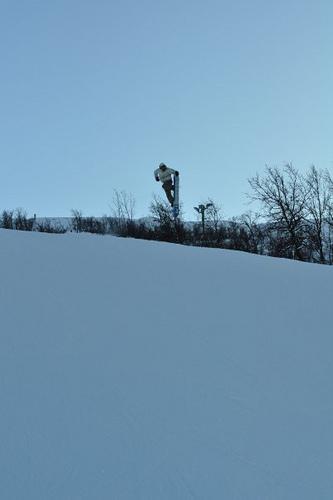Is it cold out?
Give a very brief answer. Yes. Do the skiers appear to be ascending or descending?
Quick response, please. Descending. Are there leaves on the trees?
Concise answer only. No. Are all clouds gone?
Keep it brief. Yes. 